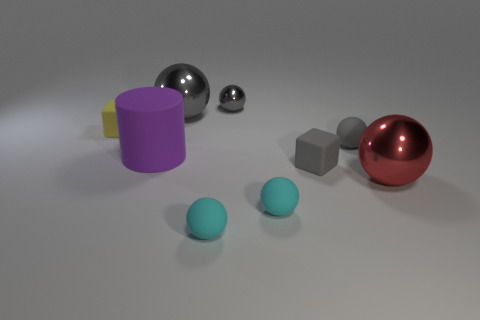The yellow thing is what size?
Make the answer very short. Small. Are the big ball that is behind the large rubber cylinder and the gray block made of the same material?
Offer a very short reply. No. How many gray metal things are there?
Provide a succinct answer. 2. What number of objects are cyan objects or matte cylinders?
Offer a terse response. 3. There is a big gray shiny ball to the left of the gray shiny thing that is right of the large gray ball; what number of small cyan balls are to the right of it?
Offer a terse response. 2. Is there anything else that is the same color as the cylinder?
Keep it short and to the point. No. There is a big sphere that is behind the tiny yellow cube; does it have the same color as the shiny sphere that is in front of the gray cube?
Provide a short and direct response. No. Are there more large gray metallic things to the left of the red metal thing than small shiny spheres that are on the right side of the tiny shiny sphere?
Make the answer very short. Yes. What material is the purple object?
Make the answer very short. Rubber. What is the shape of the purple matte object that is in front of the small gray ball behind the small matte cube left of the tiny gray metallic sphere?
Make the answer very short. Cylinder. 